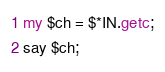Convert code to text. <code><loc_0><loc_0><loc_500><loc_500><_Perl_>my $ch = $*IN.getc;
say $ch;
</code> 